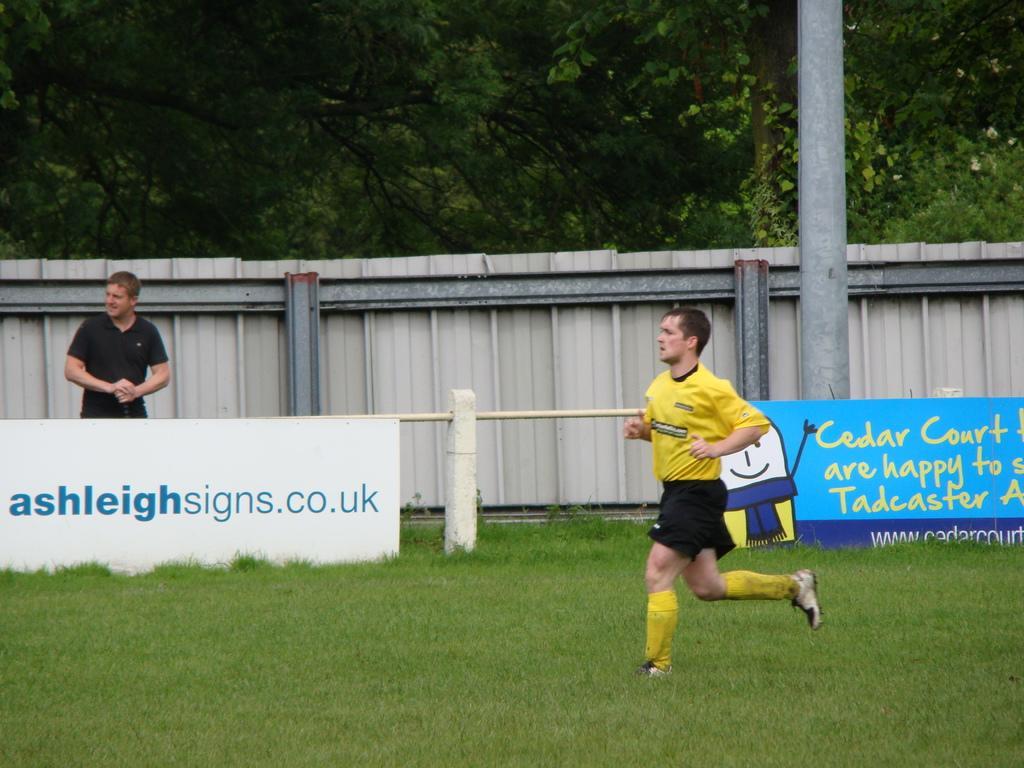Could you give a brief overview of what you see in this image? In the foreground of the picture there is a person running in the ground. In the foreground there is grass. In the center of the picture there are banners, pole, railing, a person and a wall. In the background there are trees. 